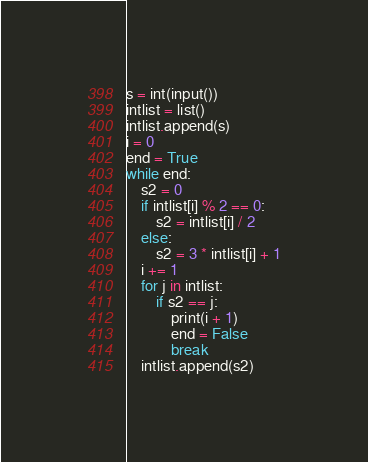<code> <loc_0><loc_0><loc_500><loc_500><_Python_>s = int(input())
intlist = list()
intlist.append(s)
i = 0
end = True
while end:
    s2 = 0
    if intlist[i] % 2 == 0:
        s2 = intlist[i] / 2
    else:
        s2 = 3 * intlist[i] + 1
    i += 1
    for j in intlist:
        if s2 == j:
            print(i + 1)
            end = False
            break
    intlist.append(s2)</code> 